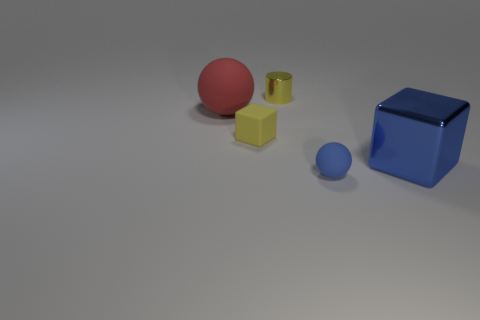Add 1 green objects. How many objects exist? 6 Subtract all cubes. How many objects are left? 3 Subtract all metal cylinders. Subtract all big cyan matte blocks. How many objects are left? 4 Add 2 large red matte balls. How many large red matte balls are left? 3 Add 2 red rubber objects. How many red rubber objects exist? 3 Subtract 0 red blocks. How many objects are left? 5 